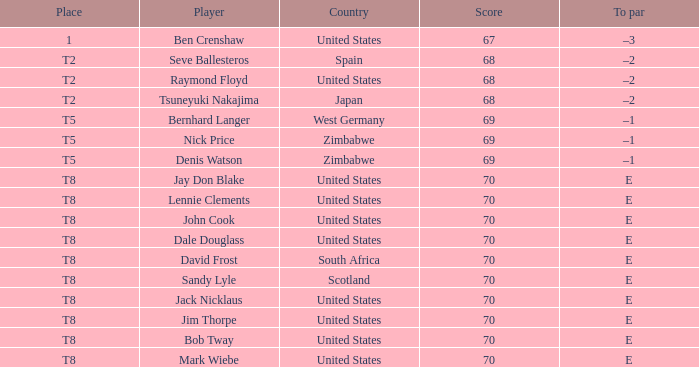What place has E as the to par, with Mark Wiebe as the player? T8. Could you parse the entire table? {'header': ['Place', 'Player', 'Country', 'Score', 'To par'], 'rows': [['1', 'Ben Crenshaw', 'United States', '67', '–3'], ['T2', 'Seve Ballesteros', 'Spain', '68', '–2'], ['T2', 'Raymond Floyd', 'United States', '68', '–2'], ['T2', 'Tsuneyuki Nakajima', 'Japan', '68', '–2'], ['T5', 'Bernhard Langer', 'West Germany', '69', '–1'], ['T5', 'Nick Price', 'Zimbabwe', '69', '–1'], ['T5', 'Denis Watson', 'Zimbabwe', '69', '–1'], ['T8', 'Jay Don Blake', 'United States', '70', 'E'], ['T8', 'Lennie Clements', 'United States', '70', 'E'], ['T8', 'John Cook', 'United States', '70', 'E'], ['T8', 'Dale Douglass', 'United States', '70', 'E'], ['T8', 'David Frost', 'South Africa', '70', 'E'], ['T8', 'Sandy Lyle', 'Scotland', '70', 'E'], ['T8', 'Jack Nicklaus', 'United States', '70', 'E'], ['T8', 'Jim Thorpe', 'United States', '70', 'E'], ['T8', 'Bob Tway', 'United States', '70', 'E'], ['T8', 'Mark Wiebe', 'United States', '70', 'E']]} 